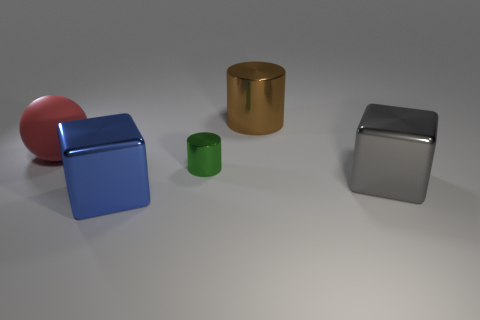Subtract all yellow blocks. Subtract all blue balls. How many blocks are left? 2 Add 1 big matte things. How many objects exist? 6 Subtract all cubes. How many objects are left? 3 Add 3 big brown metal things. How many big brown metal things are left? 4 Add 3 big cylinders. How many big cylinders exist? 4 Subtract 0 green spheres. How many objects are left? 5 Subtract all large red blocks. Subtract all big cubes. How many objects are left? 3 